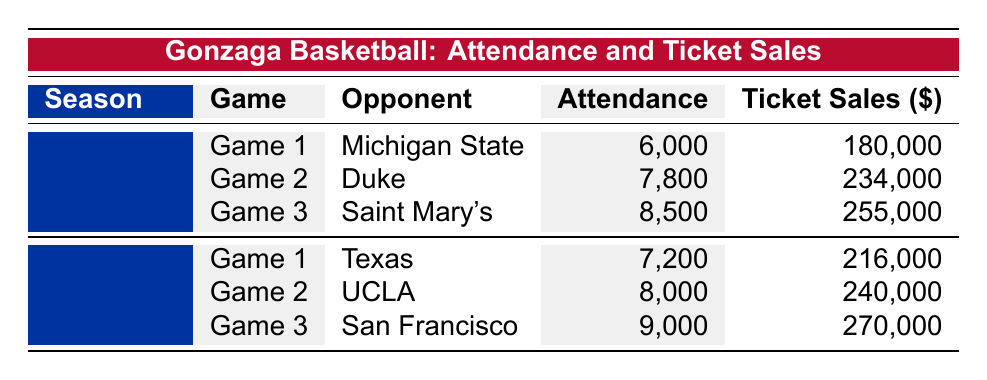What was the highest attendance recorded in the 2022-2023 season? By reviewing the attendance figures for each game in the 2022-2023 season (6000, 7800, 8500), we identify that the highest attendance is 8500 for the game against Saint Mary's.
Answer: 8500 What were the ticket sales for the game against Duke in the 2022-2023 season? The table indicates that for the game against Duke, the ticket sales amount is 234000.
Answer: 234000 Did Gonzaga play against Texas in the 2022-2023 season? Looking at the opponents listed for the 2022-2023 season (Michigan State, Duke, Saint Mary's), we see that Texas is not included. Therefore, the answer is no.
Answer: No What is the total attendance for all games in the 2021-2022 season? To find the total attendance, we add up the attendance for each game: 7200 + 8000 + 9000 = 24200. Thus, the total attendance is 24200.
Answer: 24200 What was the average ticket sales amount per game for the 2021-2022 season? First, we sum the ticket sales amounts: 216000 + 240000 + 270000 = 726000. Since there are 3 games, we divide the total by the number of games: 726000 / 3 = 242000.
Answer: 242000 Which season had a game with the greatest ticket sales, and what was that amount? In the 2021-2022 season, the game against San Francisco had ticket sales of 270000, which is greater than any ticket sales from the 2022-2023 season (with a maximum of 255000). Thus, the season with the greatest ticket sales is 2021-2022, with an amount of 270000.
Answer: 2021-2022, 270000 What is the attendance difference between the highest and lowest games in the 2022-2023 season? The highest attendance is 8500 for the game against Saint Mary's, and the lowest attendance is 6000 for the game against Michigan State. The difference is calculated as 8500 - 6000 = 2500.
Answer: 2500 Did the attendance for the game against San Francisco exceed 9000 in the 2021-2022 season? The attendance for the San Francisco game in the 2021-2022 season is 9000, which does not exceed 9000. Therefore, the answer is no.
Answer: No What was the total revenue generated from ticket sales in the 2022-2023 season? By adding all ticket sales from the 2022-2023 season, we get 180000 + 234000 + 255000 = 669000. The total revenue from ticket sales is 669000.
Answer: 669000 